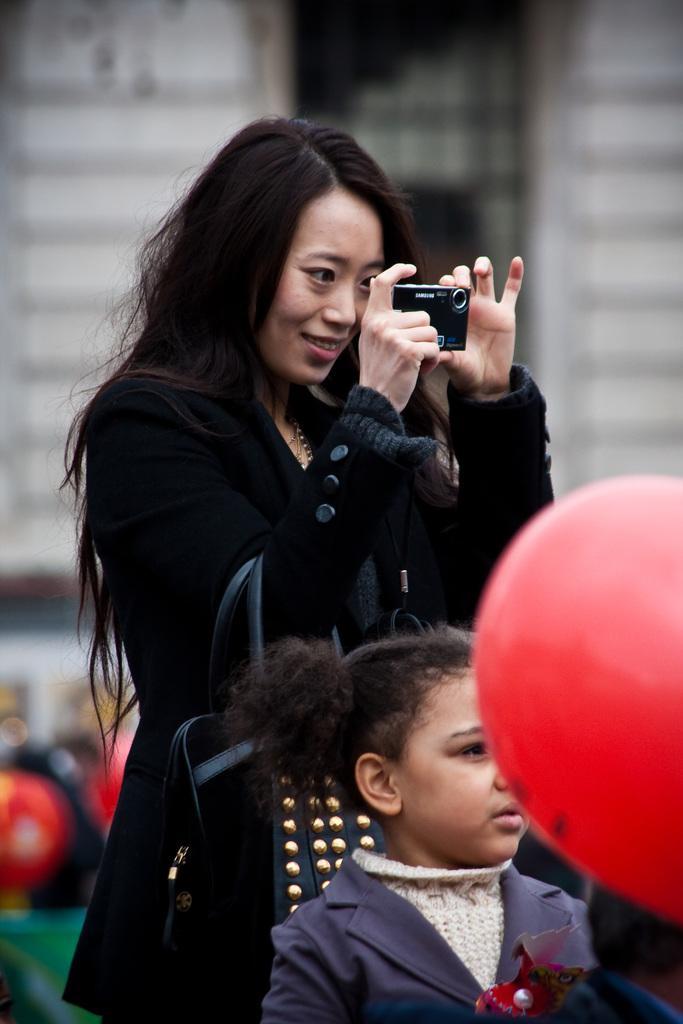Please provide a concise description of this image. In the image we can see there is a woman who is standing and she is holding a camera in her hand and she is wearing a black jacket. In Front of her there is a girl who is standing and there is a balloon which is in red colour. 